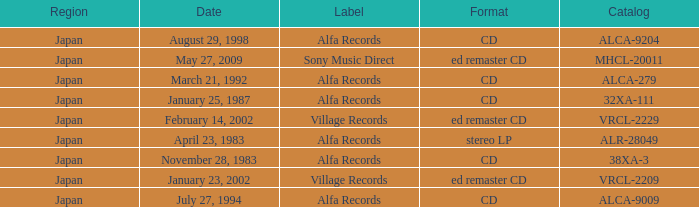Which label is dated February 14, 2002? Village Records. 